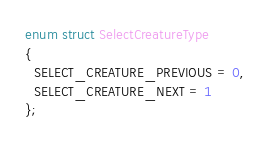Convert code to text. <code><loc_0><loc_0><loc_500><loc_500><_C++_>enum struct SelectCreatureType
{
  SELECT_CREATURE_PREVIOUS = 0,
  SELECT_CREATURE_NEXT = 1
};

</code> 